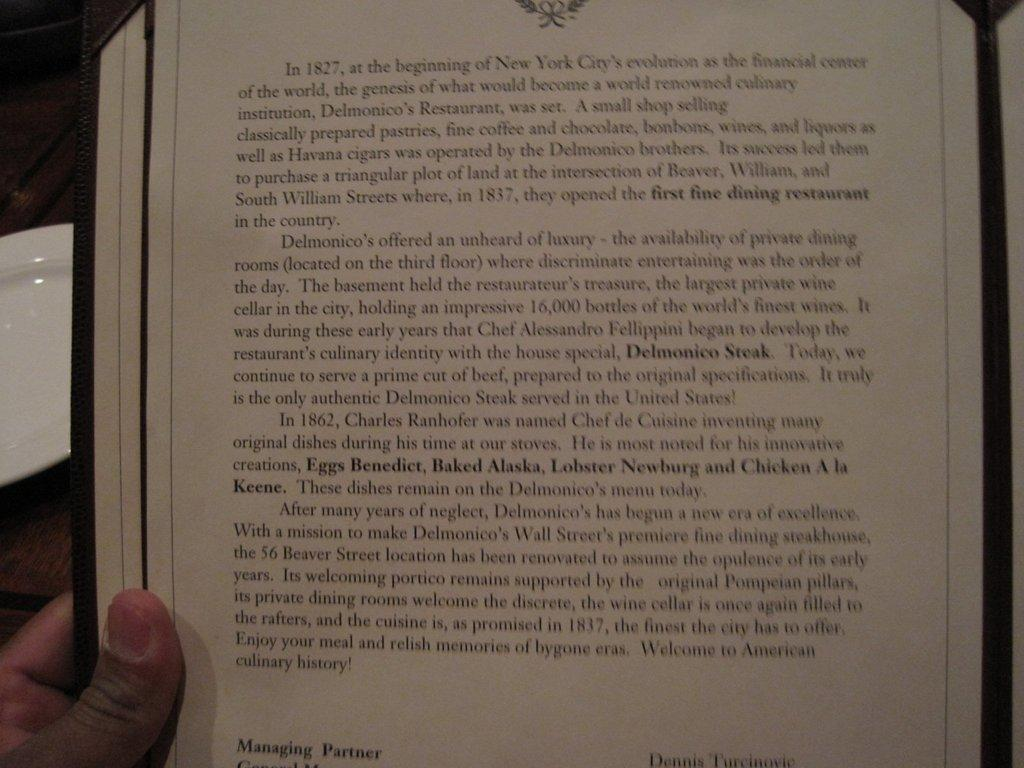<image>
Give a short and clear explanation of the subsequent image. A page of text details the history of Delmonico's Restaurant in New York City. 